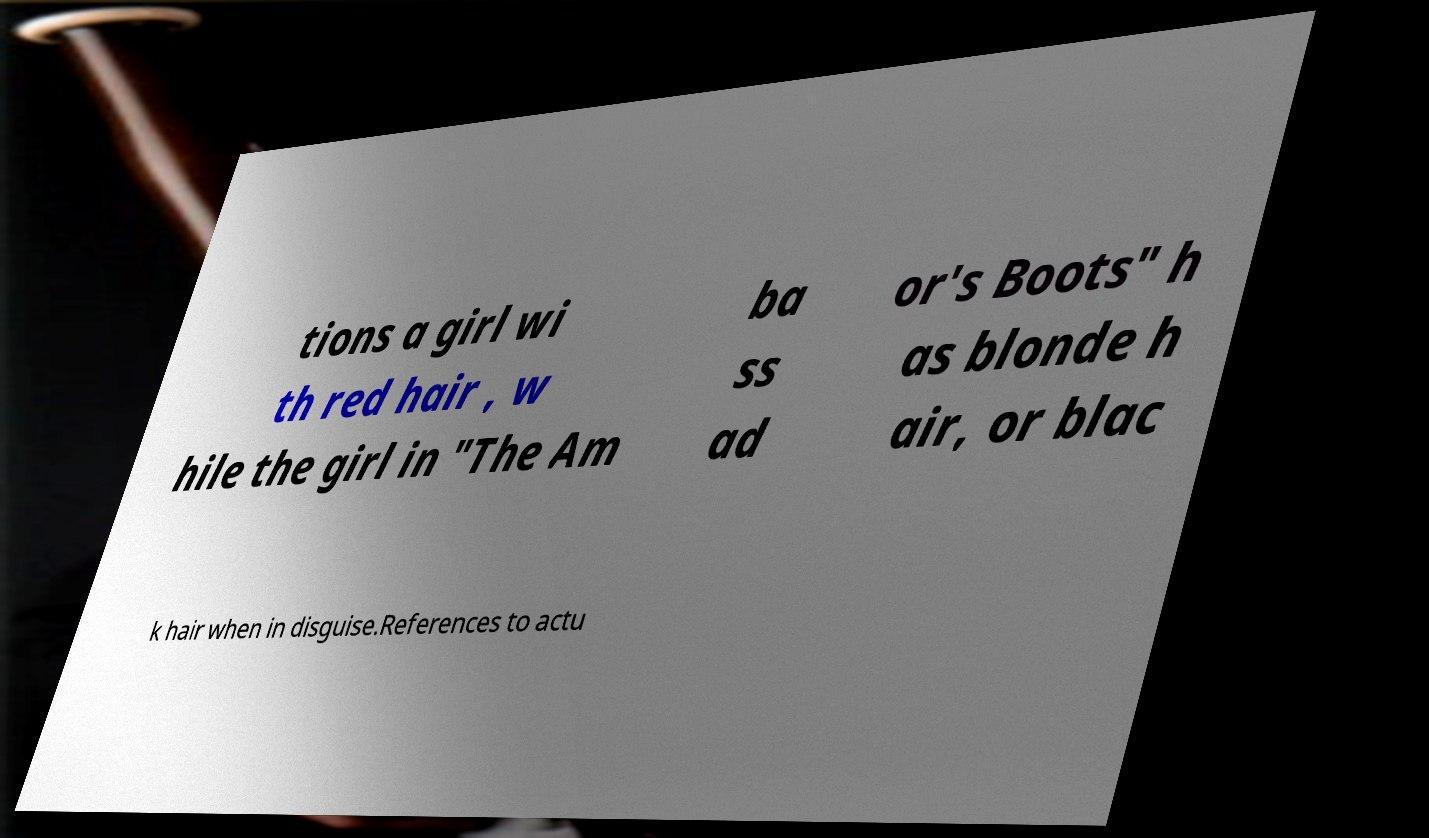Please identify and transcribe the text found in this image. tions a girl wi th red hair , w hile the girl in "The Am ba ss ad or's Boots" h as blonde h air, or blac k hair when in disguise.References to actu 